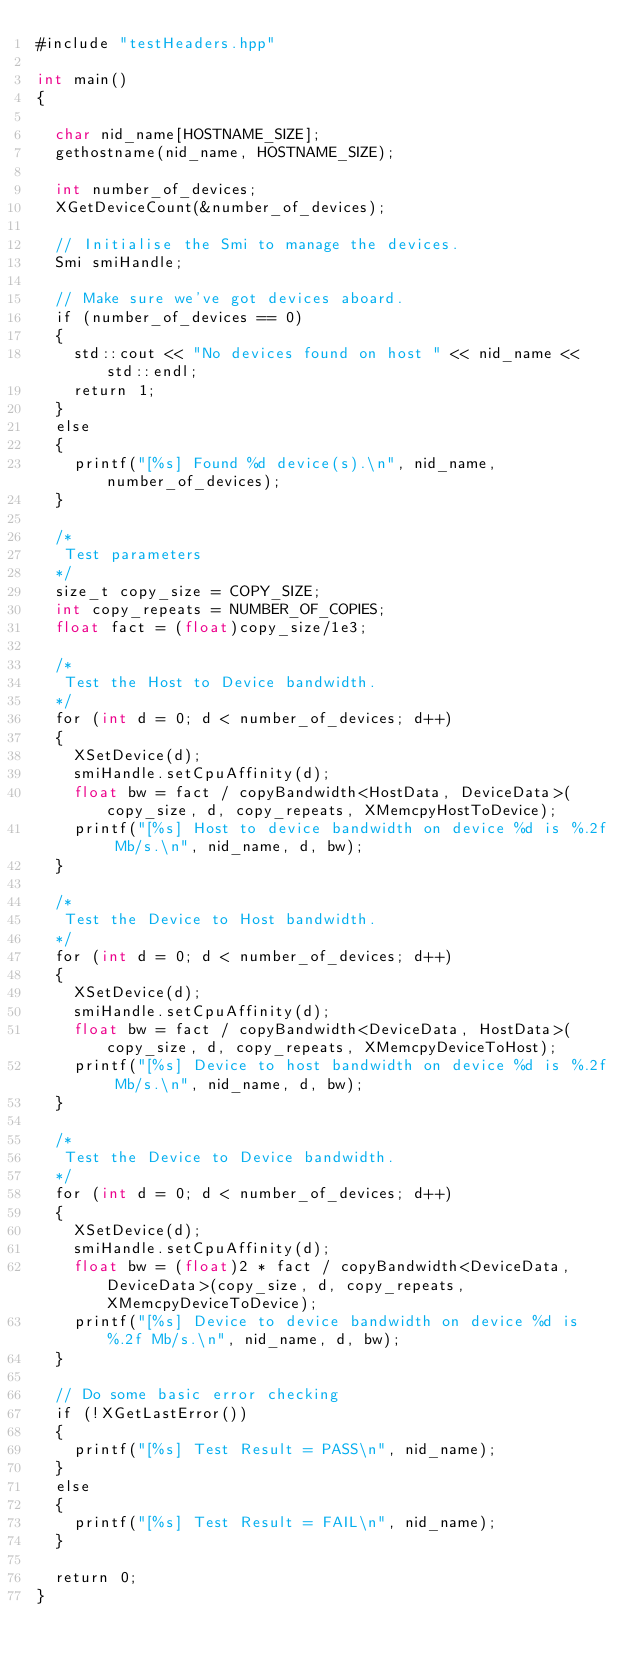<code> <loc_0><loc_0><loc_500><loc_500><_Cuda_>#include "testHeaders.hpp"

int main()
{

  char nid_name[HOSTNAME_SIZE];
  gethostname(nid_name, HOSTNAME_SIZE);

  int number_of_devices;
  XGetDeviceCount(&number_of_devices);

  // Initialise the Smi to manage the devices.
  Smi smiHandle;

  // Make sure we've got devices aboard.
  if (number_of_devices == 0)
  {
    std::cout << "No devices found on host " << nid_name << std::endl;
    return 1;
  }
  else
  {
    printf("[%s] Found %d device(s).\n", nid_name, number_of_devices);
  }

  /*
   Test parameters
  */
  size_t copy_size = COPY_SIZE;
  int copy_repeats = NUMBER_OF_COPIES;
  float fact = (float)copy_size/1e3;

  /*
   Test the Host to Device bandwidth.
  */
  for (int d = 0; d < number_of_devices; d++)
  {
    XSetDevice(d);
    smiHandle.setCpuAffinity(d);
    float bw = fact / copyBandwidth<HostData, DeviceData>(copy_size, d, copy_repeats, XMemcpyHostToDevice);
    printf("[%s] Host to device bandwidth on device %d is %.2f Mb/s.\n", nid_name, d, bw);
  }

  /*
   Test the Device to Host bandwidth.
  */
  for (int d = 0; d < number_of_devices; d++)
  {
    XSetDevice(d);
    smiHandle.setCpuAffinity(d);
    float bw = fact / copyBandwidth<DeviceData, HostData>(copy_size, d, copy_repeats, XMemcpyDeviceToHost);
    printf("[%s] Device to host bandwidth on device %d is %.2f Mb/s.\n", nid_name, d, bw);
  }

  /*
   Test the Device to Device bandwidth.
  */
  for (int d = 0; d < number_of_devices; d++)
  {
    XSetDevice(d);
    smiHandle.setCpuAffinity(d);
    float bw = (float)2 * fact / copyBandwidth<DeviceData, DeviceData>(copy_size, d, copy_repeats, XMemcpyDeviceToDevice);
    printf("[%s] Device to device bandwidth on device %d is %.2f Mb/s.\n", nid_name, d, bw);
  }

  // Do some basic error checking
  if (!XGetLastError())
  {
    printf("[%s] Test Result = PASS\n", nid_name);
  }
  else
  {
    printf("[%s] Test Result = FAIL\n", nid_name);
  }

  return 0;
}
</code> 